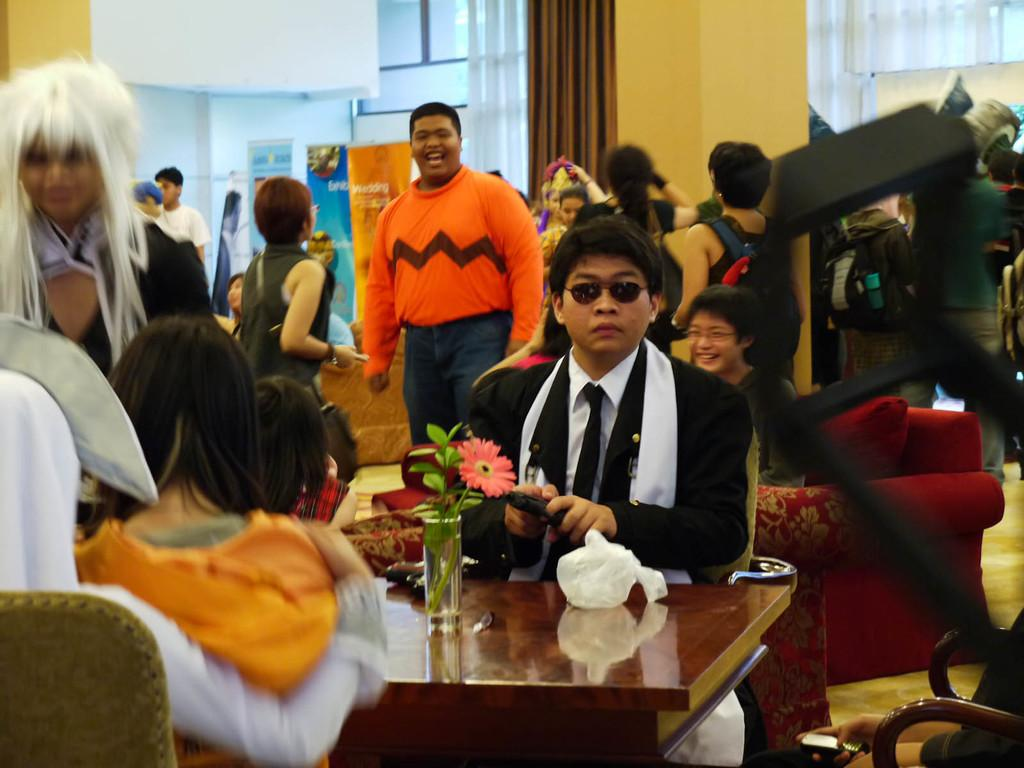What is the color of the wall in the image? The wall in the image is white. What can be seen hanging on the wall? There is a banner in the image. What type of window treatment is present in the image? There is a curtain in the image. What are the people in the image doing? The people are sitting on chairs in the image. What piece of furniture is present in the image? There is a table in the image. What type of ship can be seen sailing in the background of the image? There is no ship visible in the image; it only features a white wall, a banner, a curtain, people sitting on chairs, and a table. 